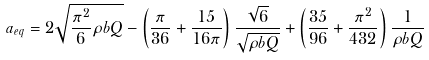Convert formula to latex. <formula><loc_0><loc_0><loc_500><loc_500>a _ { e q } = 2 \sqrt { \frac { \pi ^ { 2 } } { 6 } \rho b Q } - \left ( \frac { \pi } { 3 6 } + \frac { 1 5 } { 1 6 \pi } \right ) \frac { \sqrt { 6 } } { \sqrt { \rho b Q } } + \left ( \frac { 3 5 } { 9 6 } + \frac { \pi ^ { 2 } } { 4 3 2 } \right ) \frac { 1 } { \rho b Q }</formula> 